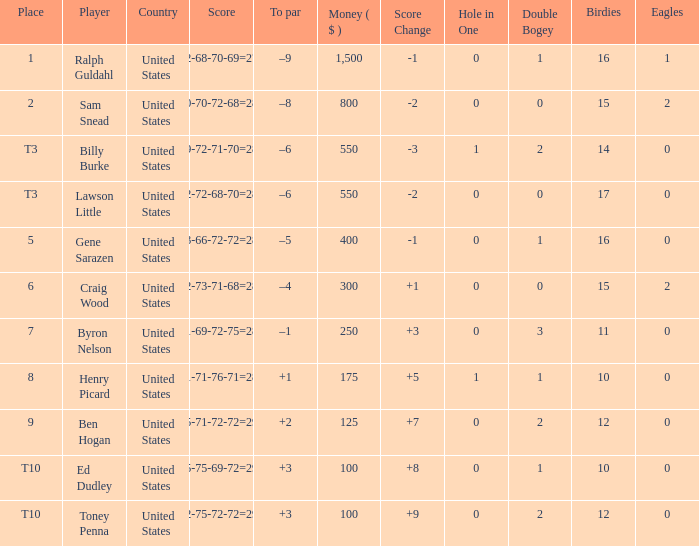Which to par has a prize less than $800? –8. 